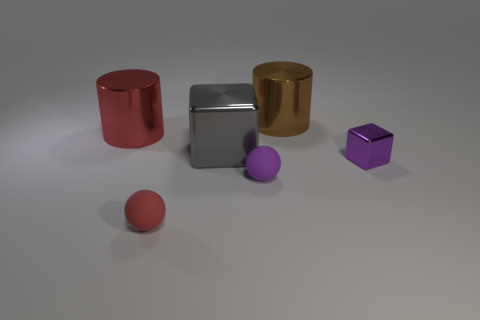There is a large thing that is right of the metallic cube that is on the left side of the purple metallic cube; what number of tiny spheres are left of it?
Provide a short and direct response. 2. How many things are to the right of the big cylinder that is behind the big red cylinder?
Provide a short and direct response. 1. How many tiny objects are to the right of the small purple ball?
Your answer should be very brief. 1. What number of other things are there of the same size as the gray cube?
Your answer should be compact. 2. There is another object that is the same shape as the purple matte thing; what is its size?
Your answer should be compact. Small. There is a small thing on the right side of the brown metal cylinder; what is its shape?
Offer a very short reply. Cube. There is a large thing to the left of the big thing in front of the big red metal cylinder; what is its color?
Offer a terse response. Red. What number of objects are either cylinders that are to the right of the small purple sphere or brown matte spheres?
Give a very brief answer. 1. There is a brown metal cylinder; is its size the same as the sphere that is right of the small red matte sphere?
Keep it short and to the point. No. What number of big objects are either blocks or brown metallic objects?
Make the answer very short. 2. 